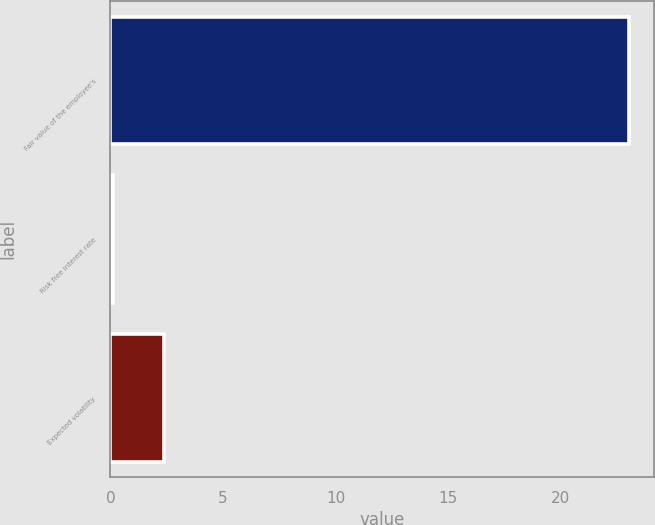Convert chart. <chart><loc_0><loc_0><loc_500><loc_500><bar_chart><fcel>Fair value of the employee's<fcel>Risk free interest rate<fcel>Expected volatility<nl><fcel>23.02<fcel>0.1<fcel>2.39<nl></chart> 